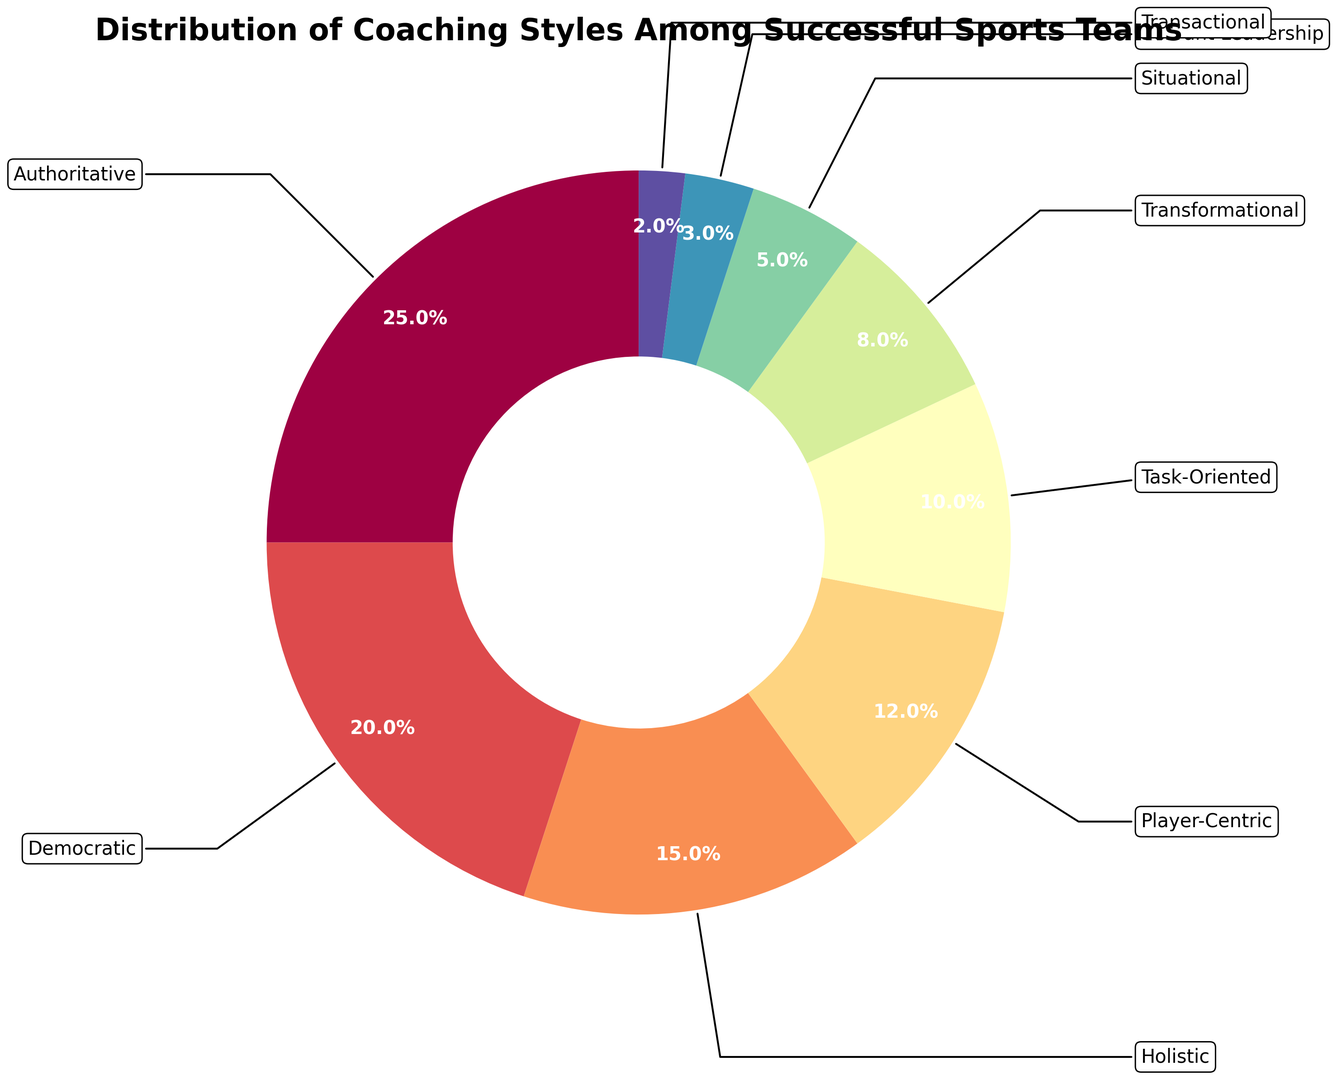Which coaching style has the highest percentage? The chart shows multiple coaching styles with corresponding percentages. By looking at the chart, the largest slice is for "Authoritative".
Answer: Authoritative Which coaching style has a higher percentage, Democratic or Task-Oriented? By comparing the sizes of the slices for Democratic and Task-Oriented coaching styles, Democratic is larger with 20% compared to Task-Oriented's 10%.
Answer: Democratic What is the combined percentage of Holistic and Player-Centric coaching styles? According to the chart, Holistic is 15% and Player-Centric is 12%. Adding these up: 15% + 12% = 27%.
Answer: 27% How many coaching styles have a percentage lower than 10%? Identifying the slices with less than 10%, they are: Transformational (8%), Situational (5%), Servant Leadership (3%), and Transactional (2%). There are four such styles.
Answer: 4 Which coaching style has the smallest percentage? The smallest slice on the chart is labeled "Transactional" and has a percentage of 2%.
Answer: Transactional Is the percentage of Authoritative coaching style greater than the combined percentage of Transactional, Servant Leadership, and Situational coaching styles? The Authoritative style has 25%. Summing the percentages of Transactional (2%), Servant Leadership (3%), and Situational (5%) gives 2% + 3% + 5% = 10%. Since 25% is greater than 10%, the answer is yes.
Answer: Yes What is the percentage difference between the highest and lowest coaching styles? The highest percentage is Authoritative (25%) and the lowest is Transactional (2%). The difference is 25% - 2% = 23%.
Answer: 23% Which coaching styles constitute exactly 50% of the distribution when combined? Combining the slices: Authoritative (25%) + Democratic (20%) + Holistic (15%) = 60%. This exceeds 50%, but no smaller combinations add up to precisely 50%. However, adding together the percentages doesn't yield an exact combination for 50%.
Answer: None 